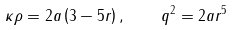Convert formula to latex. <formula><loc_0><loc_0><loc_500><loc_500>\kappa \rho = 2 a \left ( 3 - 5 r \right ) , \quad q ^ { 2 } = 2 a r ^ { 5 }</formula> 